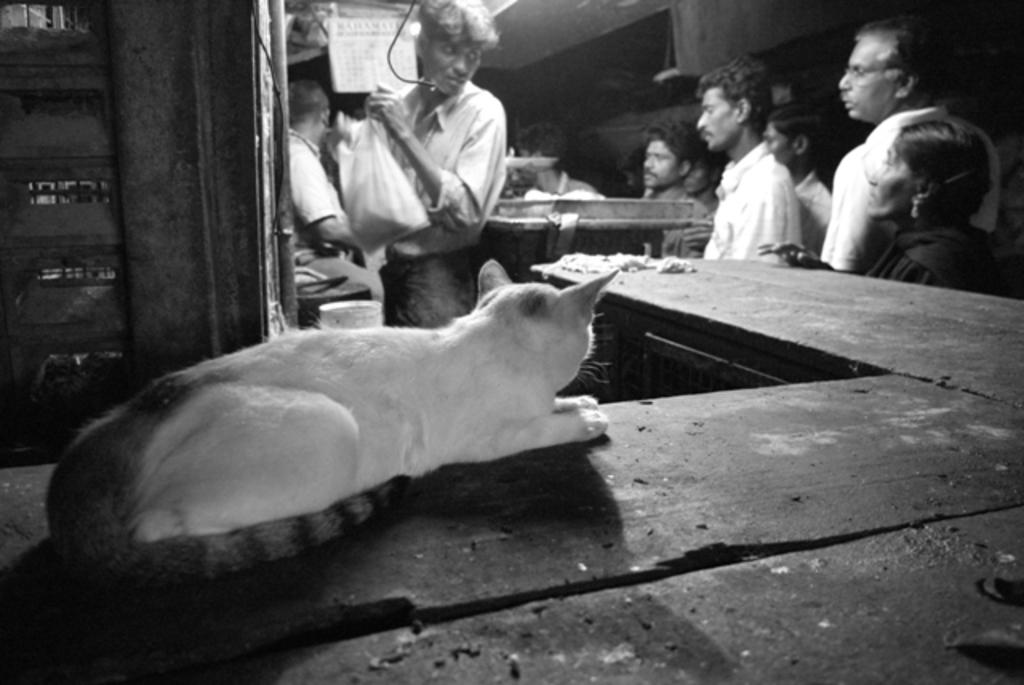What animal is sitting on the table in the image? There is a cat sitting on the table in the image. Can you describe the people in the image? There are people in the image, but their specific actions or characteristics are not mentioned in the provided facts. What is the man holding in the image? The man is holding a cover. What impulse can be seen affecting the cat's behavior in the image? There is no mention of any impulse affecting the cat's behavior in the image. How does the cat draw attention to itself in the image? The cat's sitting position on the table may draw attention, but the provided facts do not specifically mention this. 